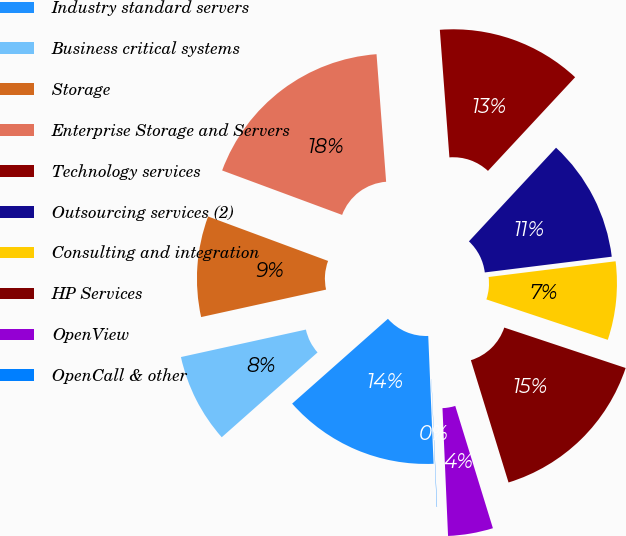Convert chart. <chart><loc_0><loc_0><loc_500><loc_500><pie_chart><fcel>Industry standard servers<fcel>Business critical systems<fcel>Storage<fcel>Enterprise Storage and Servers<fcel>Technology services<fcel>Outsourcing services (2)<fcel>Consulting and integration<fcel>HP Services<fcel>OpenView<fcel>OpenCall & other<nl><fcel>14.13%<fcel>8.09%<fcel>9.09%<fcel>18.16%<fcel>13.12%<fcel>11.11%<fcel>7.08%<fcel>15.13%<fcel>4.06%<fcel>0.03%<nl></chart> 